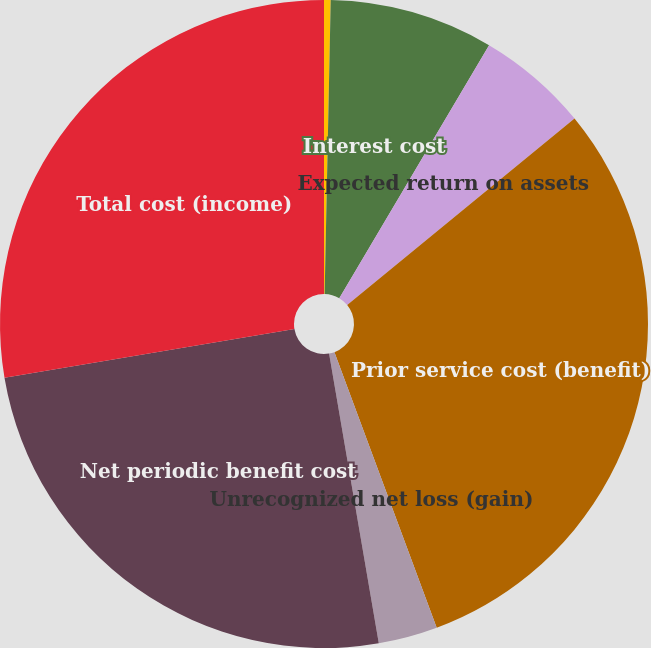Convert chart to OTSL. <chart><loc_0><loc_0><loc_500><loc_500><pie_chart><fcel>Service cost<fcel>Interest cost<fcel>Expected return on assets<fcel>Prior service cost (benefit)<fcel>Unrecognized net loss (gain)<fcel>Net periodic benefit cost<fcel>Total cost (income)<nl><fcel>0.33%<fcel>8.18%<fcel>5.56%<fcel>30.28%<fcel>2.95%<fcel>25.05%<fcel>27.66%<nl></chart> 